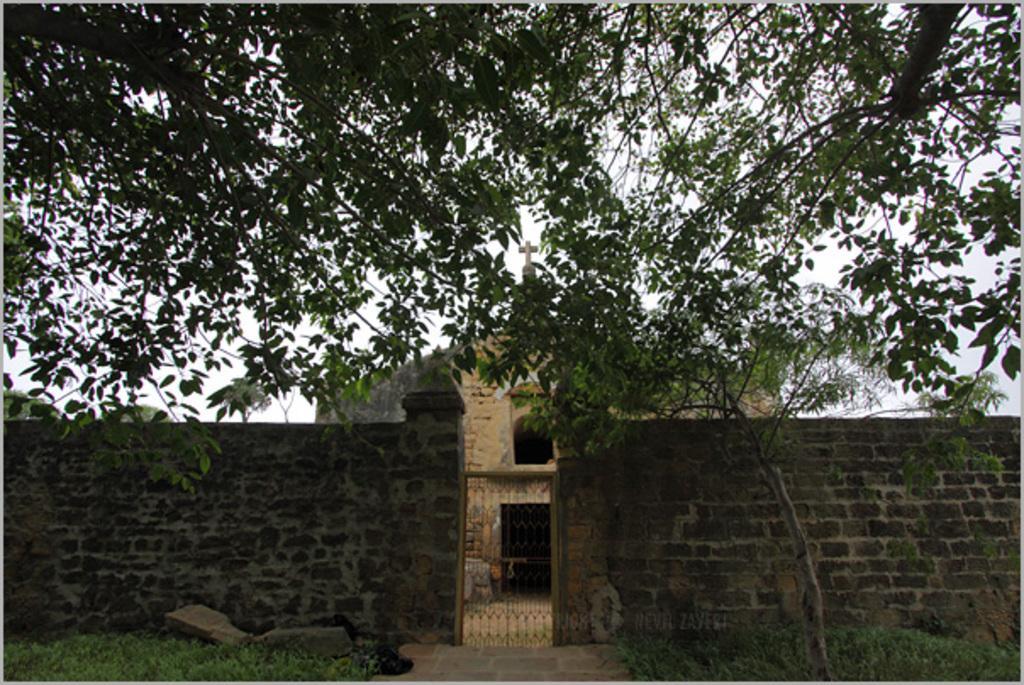Please provide a concise description of this image. In this image, we can see the wall. We can also see the gate and the ground. We can see some grass, rocks. We can also see a house. There are a few trees. We can also see the sky. 